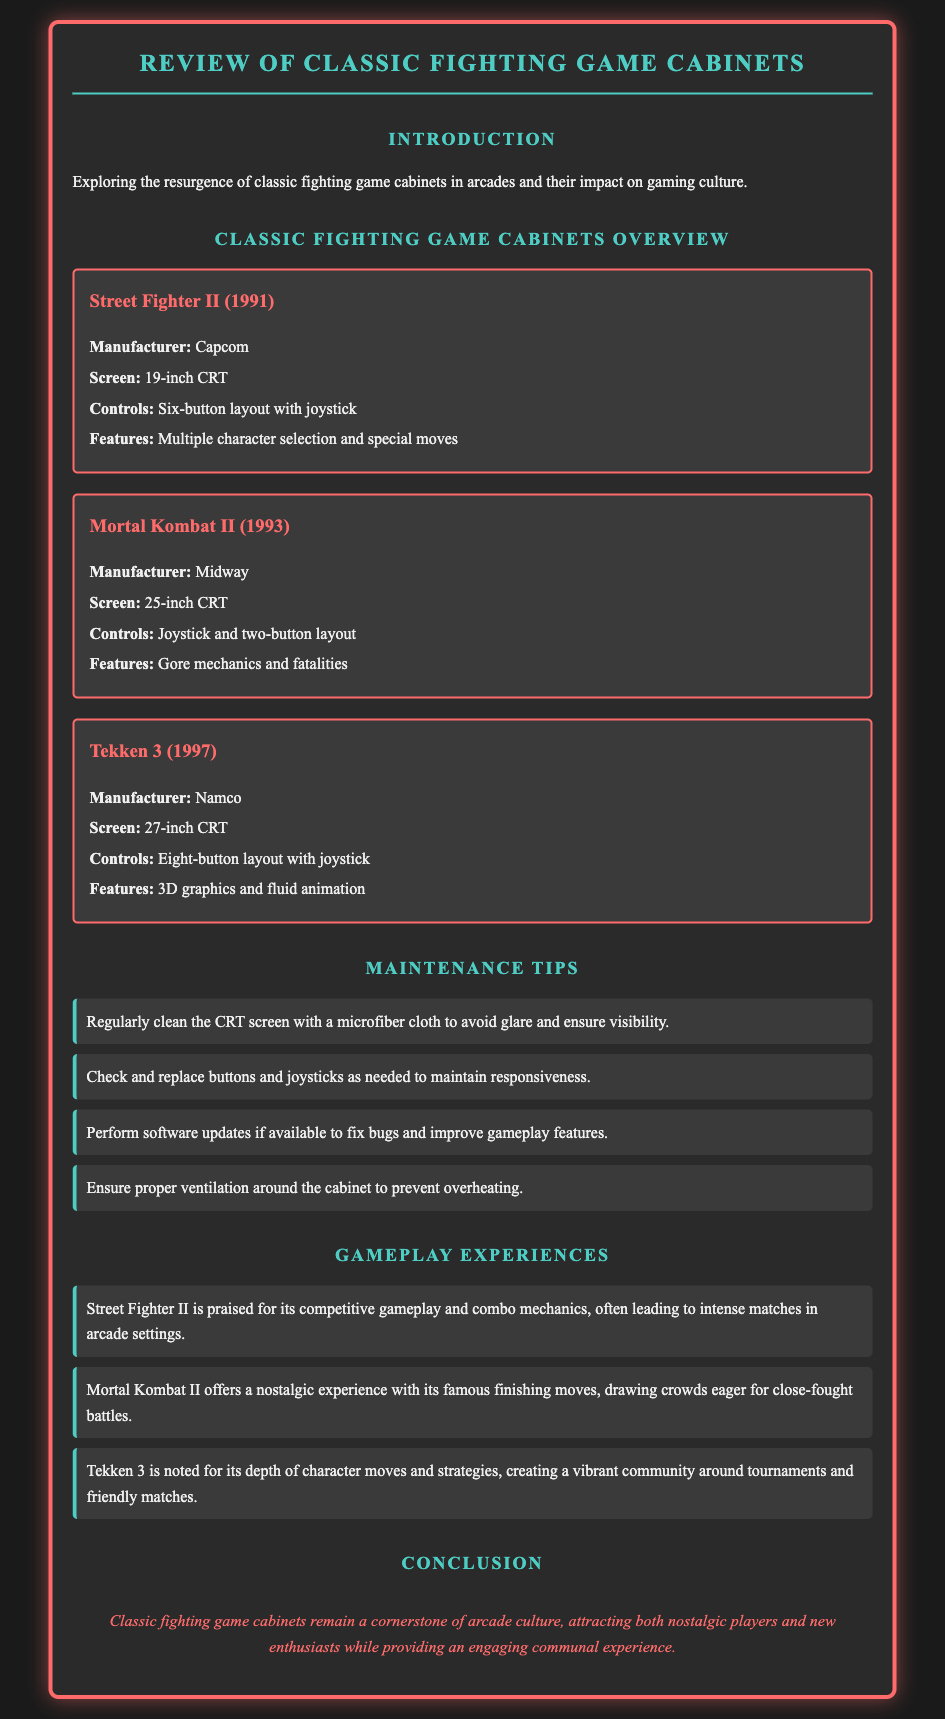what year was Street Fighter II released? The release year of Street Fighter II is stated in the document as 1991.
Answer: 1991 what screen size does Mortal Kombat II feature? The document specifies that Mortal Kombat II features a 25-inch CRT screen.
Answer: 25-inch CRT which company manufactured Tekken 3? The document lists Namco as the manufacturer of Tekken 3.
Answer: Namco what is a maintenance tip for fighting game cabinets? The document includes several maintenance tips, one of which is to regularly clean the CRT screen with a microfiber cloth.
Answer: Clean the CRT screen how does Street Fighter II's gameplay experience differ from Mortal Kombat II? Street Fighter II emphasizes competitive gameplay and combo mechanics, while Mortal Kombat II is known for its finishing moves.
Answer: Competitive gameplay vs. finishing moves how many buttons does the control layout for Tekken 3 have? The document indicates that Tekken 3 has an eight-button layout with a joystick.
Answer: Eight-button layout what feature is highlighted for Mortal Kombat II? The document highlights that Mortal Kombat II includes gore mechanics and fatalities.
Answer: Gore mechanics and fatalities what is the main theme of the document's conclusion? The conclusion of the document discusses the significance of classic fighting game cabinets in arcade culture.
Answer: Significance in arcade culture 